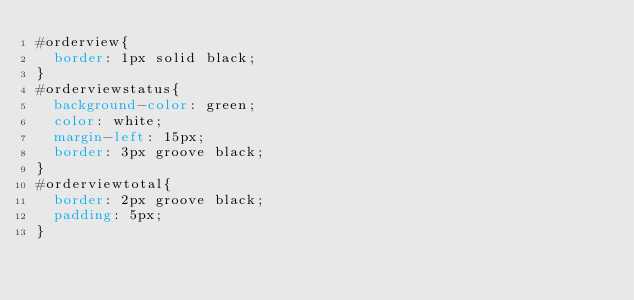<code> <loc_0><loc_0><loc_500><loc_500><_CSS_>#orderview{
	border: 1px solid black;
}
#orderviewstatus{
	background-color: green;
	color: white;
	margin-left: 15px;
	border: 3px groove black;
}
#orderviewtotal{
	border: 2px groove black;
	padding: 5px;
}</code> 